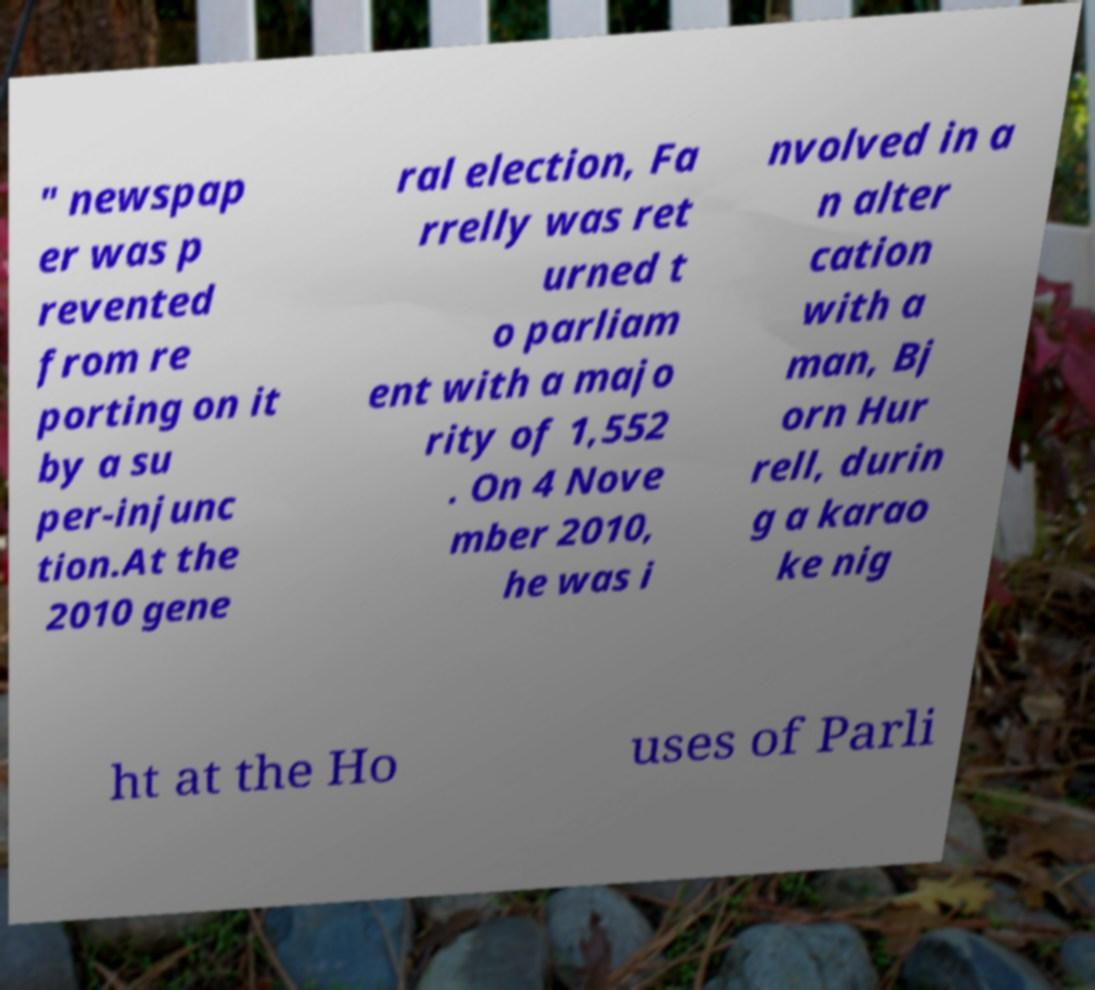There's text embedded in this image that I need extracted. Can you transcribe it verbatim? " newspap er was p revented from re porting on it by a su per-injunc tion.At the 2010 gene ral election, Fa rrelly was ret urned t o parliam ent with a majo rity of 1,552 . On 4 Nove mber 2010, he was i nvolved in a n alter cation with a man, Bj orn Hur rell, durin g a karao ke nig ht at the Ho uses of Parli 